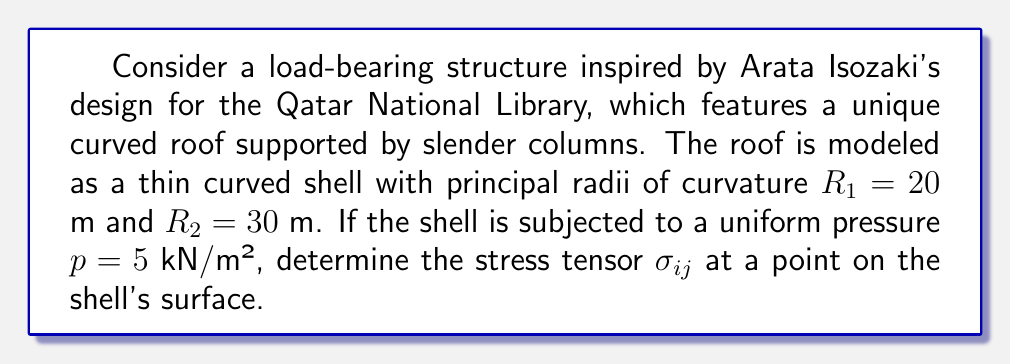Give your solution to this math problem. To determine the stress tensor for this curved shell structure, we'll follow these steps:

1) For a thin curved shell under uniform pressure, we can use the membrane theory of shells. The stress tensor will have only in-plane components, denoted as $N_1$ and $N_2$.

2) The equilibrium equations for a doubly curved shell under uniform pressure are:

   $$\frac{N_1}{R_1} + \frac{N_2}{R_2} = p$$

3) For a shell of revolution (which we can assume for this simplified model), we have:

   $$N_1 = \frac{pR_1R_2}{R_1 + R_2}$$
   $$N_2 = \frac{pR_1R_2}{R_1 + R_2} + \frac{pR_2^2}{R_1 + R_2}$$

4) Substituting the given values:

   $$N_1 = \frac{5 \cdot 20 \cdot 30}{20 + 30} = 60 \text{ kN/m}$$
   $$N_2 = \frac{5 \cdot 20 \cdot 30}{20 + 30} + \frac{5 \cdot 30^2}{20 + 30} = 60 + 90 = 150 \text{ kN/m}$$

5) The stress tensor in matrix form is:

   $$\sigma_{ij} = \begin{bmatrix}
   N_1 & 0 & 0 \\
   0 & N_2 & 0 \\
   0 & 0 & 0
   \end{bmatrix}$$

6) Substituting the calculated values:

   $$\sigma_{ij} = \begin{bmatrix}
   60 & 0 & 0 \\
   0 & 150 & 0 \\
   0 & 0 & 0
   \end{bmatrix} \text{ kN/m}$$
Answer: $$\sigma_{ij} = \begin{bmatrix}
60 & 0 & 0 \\
0 & 150 & 0 \\
0 & 0 & 0
\end{bmatrix} \text{ kN/m}$$ 